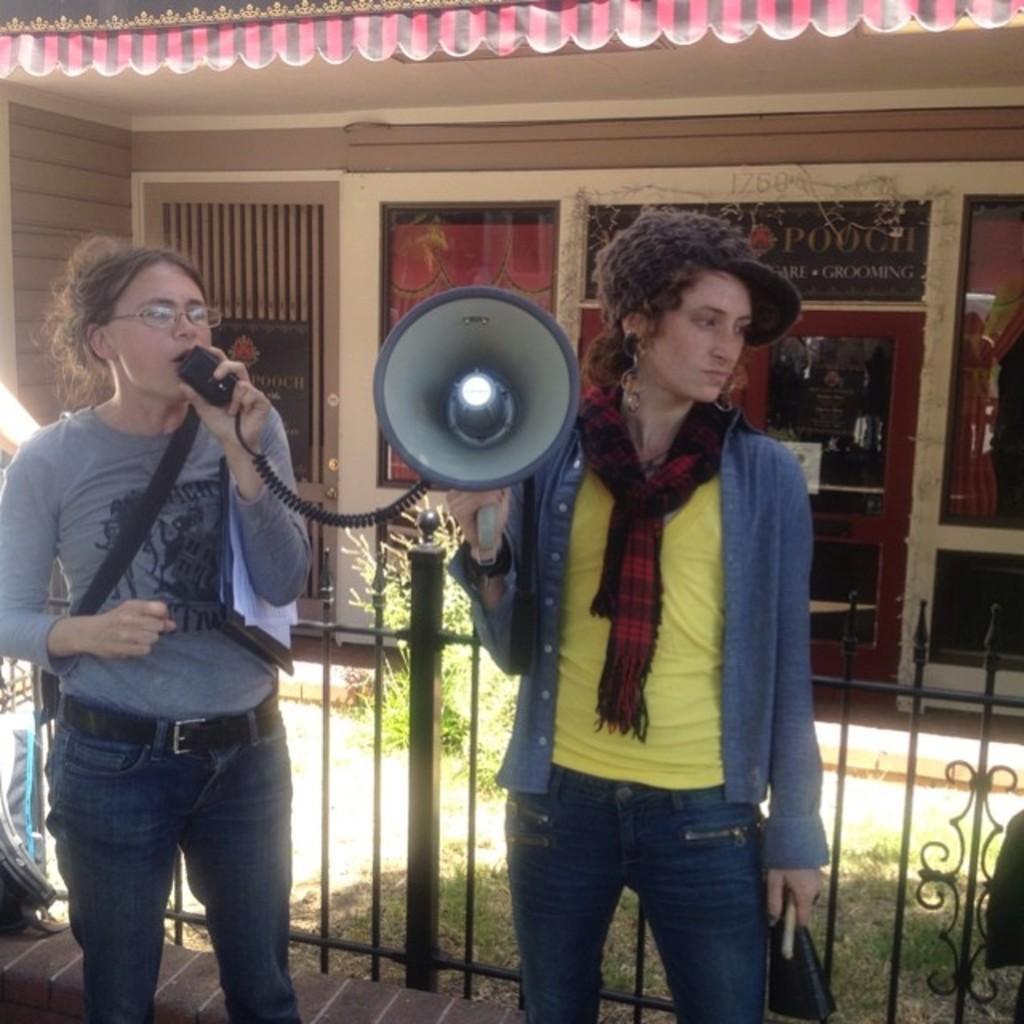How would you summarize this image in a sentence or two? In this image I can see two people with different color dresses. I can see one person with the cap and also holding the megaphone. I can see another person holding the mic. In the background I can see the railing, planter, building with many boards. 